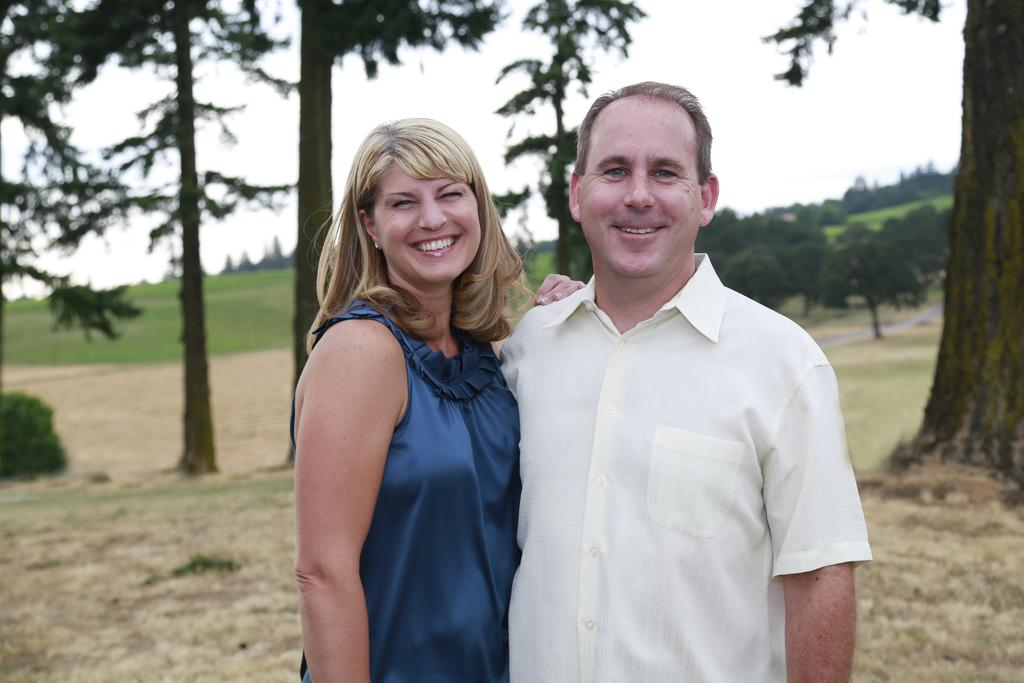How many people are present in the image? There are two people, a man and a woman, present in the image. What are the people in the image doing? Both the man and the woman are standing and smiling. What can be seen in the background of the image? There is sky, trees, grass, and other objects visible in the background of the image. How many pairs of shoes can be seen on the cow in the image? There is no cow present in the image, and therefore no shoes can be seen on a cow. 